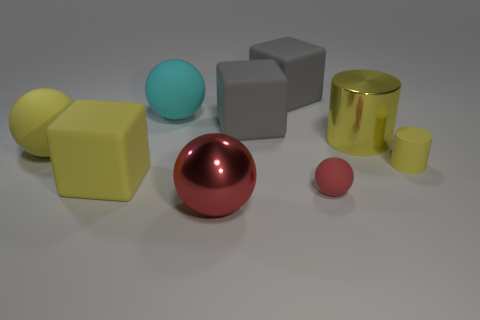Subtract 1 blocks. How many blocks are left? 2 Add 1 small red things. How many objects exist? 10 Subtract all brown spheres. Subtract all cyan cylinders. How many spheres are left? 4 Subtract all cylinders. How many objects are left? 7 Add 3 tiny purple rubber cylinders. How many tiny purple rubber cylinders exist? 3 Subtract 2 gray blocks. How many objects are left? 7 Subtract all big green metallic objects. Subtract all red balls. How many objects are left? 7 Add 4 large yellow cylinders. How many large yellow cylinders are left? 5 